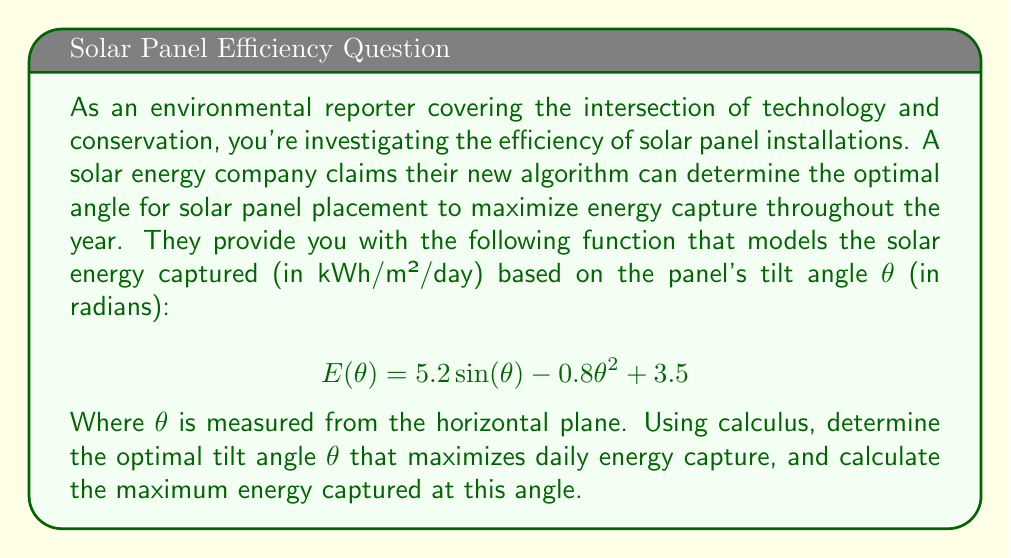Provide a solution to this math problem. To solve this problem, we'll use differential calculus to find the maximum of the given function.

1. First, we need to find the derivative of E(θ) with respect to θ:

   $$\frac{dE}{d\theta} = 5.2 \cos(\theta) - 1.6\theta$$

2. To find the maximum, we set the derivative equal to zero and solve for θ:

   $$5.2 \cos(\theta) - 1.6\theta = 0$$

3. This equation cannot be solved algebraically, so we need to use numerical methods. Using a graphing calculator or computer software, we can find that the solution is approximately:

   $$\theta \approx 0.8861 \text{ radians}$$

4. To confirm this is a maximum, we can check the second derivative:

   $$\frac{d^2E}{d\theta^2} = -5.2 \sin(\theta) - 1.6$$

   At θ ≈ 0.8861, this is negative, confirming a local maximum.

5. To calculate the maximum energy captured, we substitute this value back into the original function:

   $$E(0.8861) = 5.2 \sin(0.8861) - 0.8(0.8861)^2 + 3.5$$
   
   $$E(0.8861) \approx 7.1374 \text{ kWh/m²/day}$$

6. Converting the angle to degrees:

   $$0.8861 \text{ radians} \times \frac{180°}{\pi} \approx 50.77°$$

Therefore, the optimal tilt angle is approximately 50.77° from the horizontal, and at this angle, the maximum energy captured is about 7.1374 kWh/m²/day.
Answer: The optimal tilt angle is approximately 50.77° from the horizontal, capturing a maximum of about 7.1374 kWh/m²/day. 